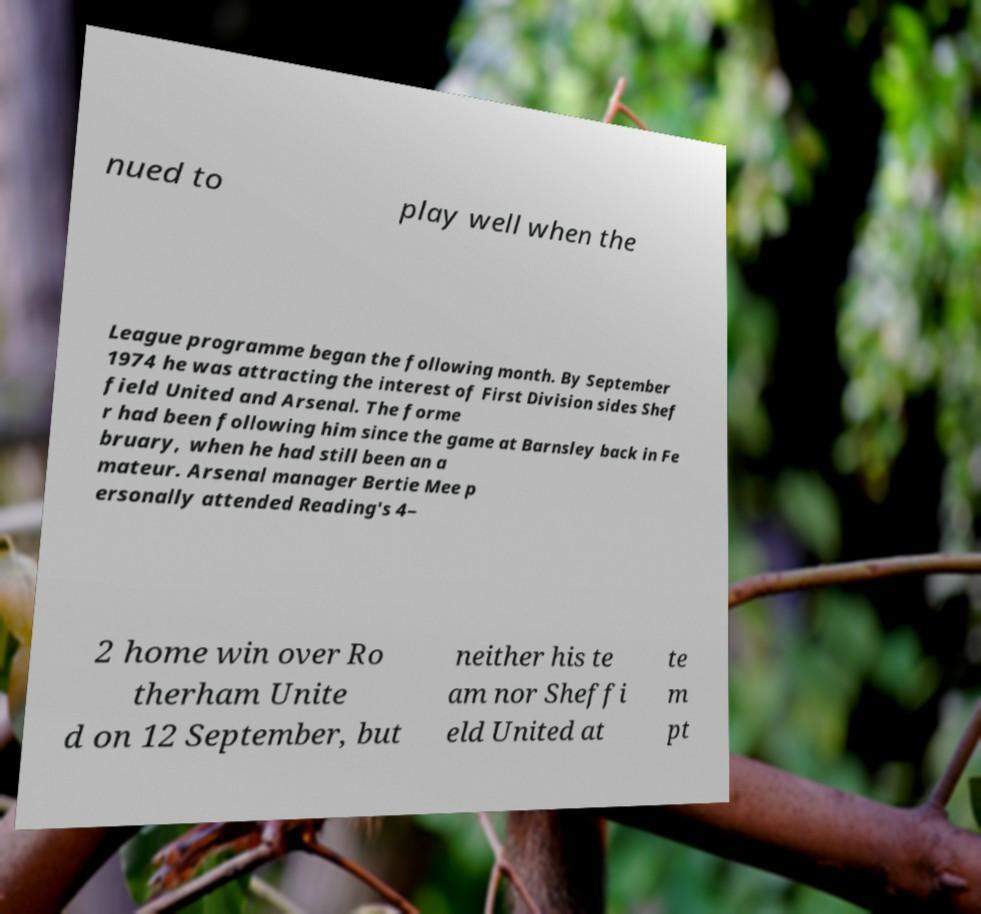Could you assist in decoding the text presented in this image and type it out clearly? nued to play well when the League programme began the following month. By September 1974 he was attracting the interest of First Division sides Shef field United and Arsenal. The forme r had been following him since the game at Barnsley back in Fe bruary, when he had still been an a mateur. Arsenal manager Bertie Mee p ersonally attended Reading's 4– 2 home win over Ro therham Unite d on 12 September, but neither his te am nor Sheffi eld United at te m pt 